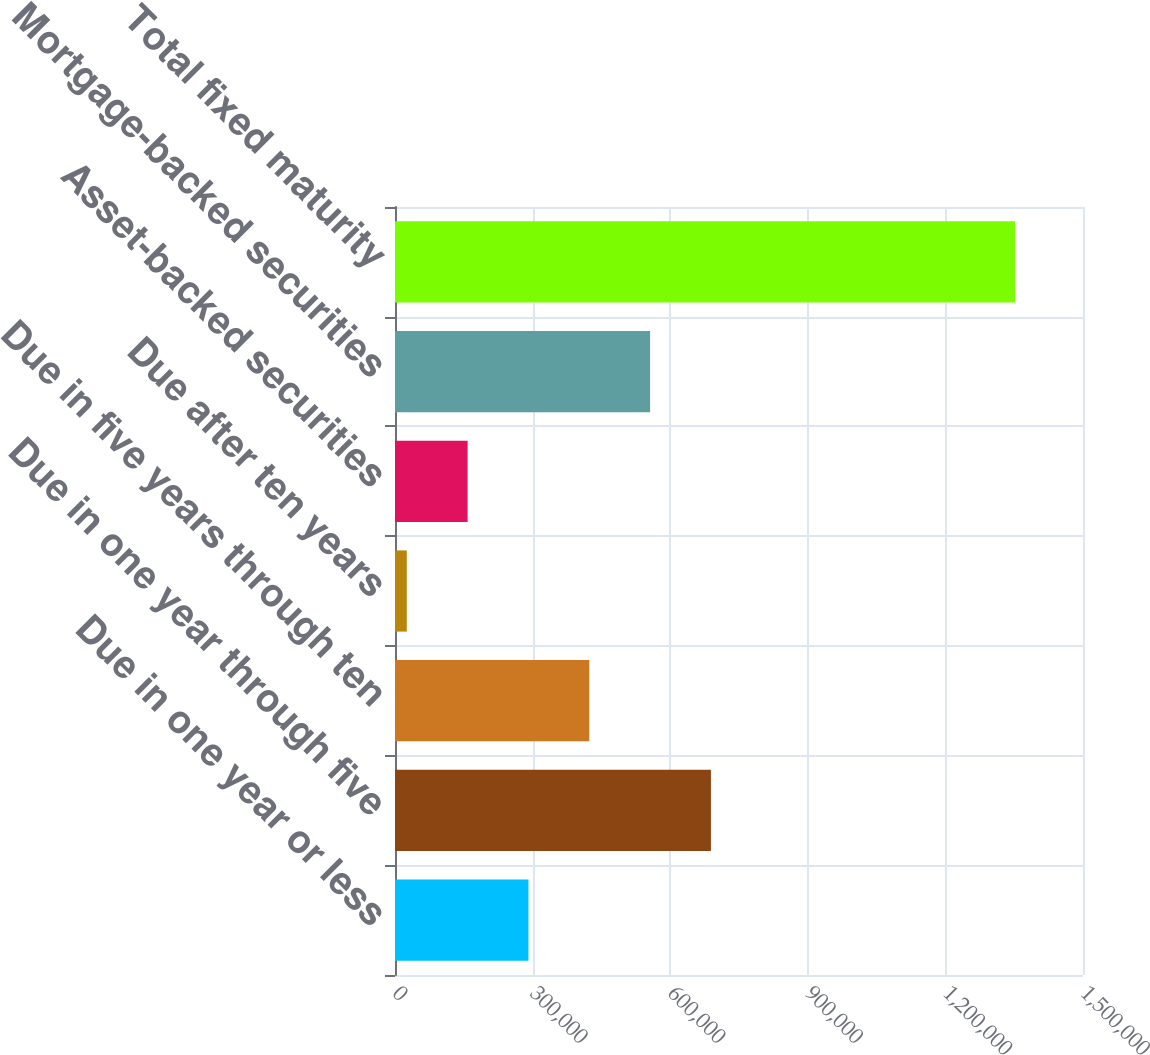<chart> <loc_0><loc_0><loc_500><loc_500><bar_chart><fcel>Due in one year or less<fcel>Due in one year through five<fcel>Due in five years through ten<fcel>Due after ten years<fcel>Asset-backed securities<fcel>Mortgage-backed securities<fcel>Total fixed maturity<nl><fcel>290947<fcel>688776<fcel>423556<fcel>25727<fcel>158337<fcel>556166<fcel>1.35182e+06<nl></chart> 